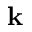Convert formula to latex. <formula><loc_0><loc_0><loc_500><loc_500>k</formula> 